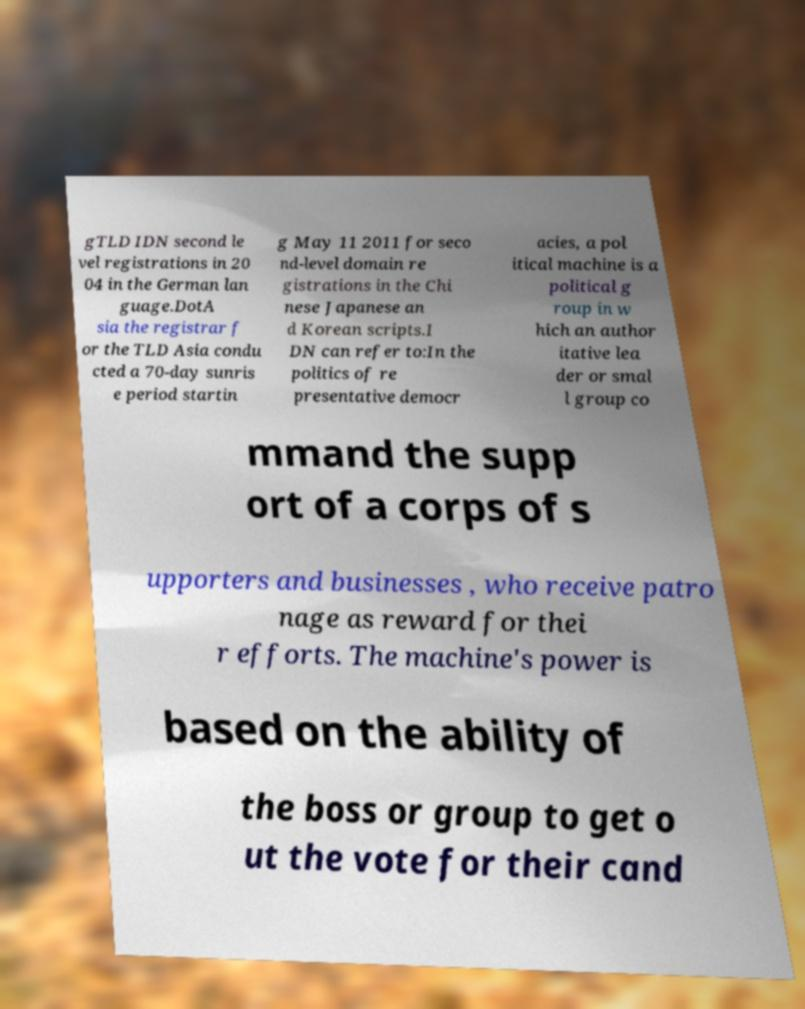Please read and relay the text visible in this image. What does it say? gTLD IDN second le vel registrations in 20 04 in the German lan guage.DotA sia the registrar f or the TLD Asia condu cted a 70-day sunris e period startin g May 11 2011 for seco nd-level domain re gistrations in the Chi nese Japanese an d Korean scripts.I DN can refer to:In the politics of re presentative democr acies, a pol itical machine is a political g roup in w hich an author itative lea der or smal l group co mmand the supp ort of a corps of s upporters and businesses , who receive patro nage as reward for thei r efforts. The machine's power is based on the ability of the boss or group to get o ut the vote for their cand 